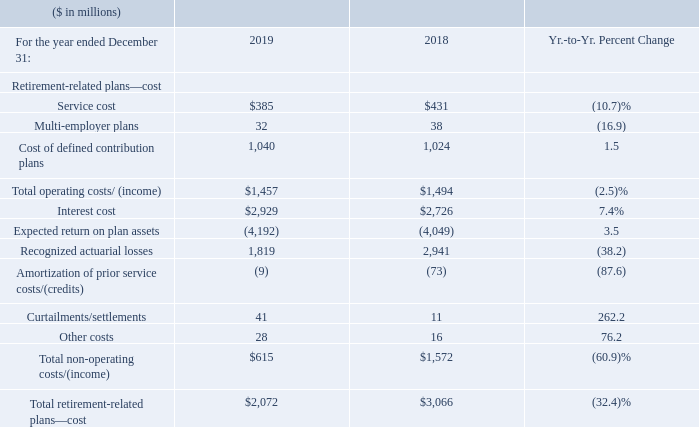Retirement-Related Plans
The following table provides the total pre-tax cost for all retirement-related plans. Total operating costs/(income) are included in the Consolidated Income Statement within the caption (e.g., Cost, SG&A, RD&E) relating to the job function of the plan participants.
Total pre-tax retirement-related plan cost decreased by $994 million compared to 2018, primarily driven by a decrease in recognized actuarial losses ($1,123 million), primarily due to the change in the amortization period in the U.S. Qualified Personal Pension Plan and higher expected return on plan assets ($143 million), partially offset by higher interest costs ($203 million).
As discussed in the “Operating (non-GAAP) Earnings” section, we characterize certain retirement-related costs as operating and others as non-operating. Utilizing this characterization, operating retirement-related costs in 2019 were $1,457 million, a decrease of $37 million compared to 2018. Non-operating costs of $615 million in 2019 decreased $957 million year to year, driven primarily by the same factors as above.
What caused the Total pre-tax retirement-related plan cost to decrease? Driven by a decrease in recognized actuarial losses ($1,123 million), primarily due to the change in the amortization period in the u.s. qualified personal pension. What caused the Non-operating costs to decrease? As discussed in the “operating (non-gaap) earnings” section, we characterize certain retirement-related costs as operating and others as non-operating. utilizing this characterization, operating retirement-related costs in 2019 were $1,457 million, a decrease of $37 million compared to 2018. non-operating costs of $615 million in 2019 decreased $957 million year to year, driven primarily by the same factors as above. What were the operating retirement related costs in 2019? $1,457 million. What was the increase / (decrease) in service cost from 2018 to 2019?
Answer scale should be: million. 385 - 431
Answer: -46. What was the average interest cost?
Answer scale should be: million. (2,929 + 2,726) / 2
Answer: 2827.5. What was the increase / (decrease) in the Other costs from 2018 to 2019?
Answer scale should be: million. 28 - 16
Answer: 12. 